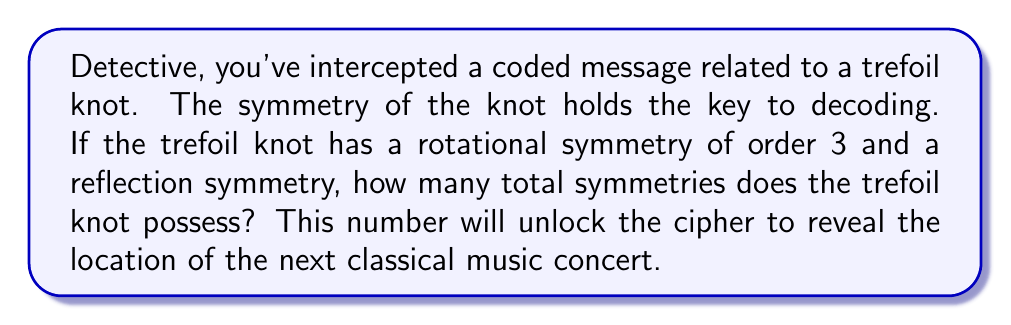Provide a solution to this math problem. Let's approach this step-by-step:

1) First, recall that the trefoil knot is chiral, meaning it's not equivalent to its mirror image.

2) The symmetries of a trefoil knot form a group. Let's identify the elements:

   a) Rotational symmetry of order 3: This means there are 3 rotations that leave the knot unchanged.
      - Identity rotation (0°)
      - Rotation by 120°
      - Rotation by 240°

   b) Reflection symmetry: There is one reflection plane.

3) Now, we need to consider the interaction of these symmetries:

   - Each rotation can be followed by either no reflection or a reflection.
   - This gives us two sets of symmetries:
     Set 1: The 3 rotations without reflection
     Set 2: The 3 rotations followed by the reflection

4) To calculate the total number of symmetries:
   $$\text{Total symmetries} = |\text{Set 1}| + |\text{Set 2}| = 3 + 3 = 6$$

5) This result is consistent with the fact that the symmetry group of the trefoil knot is isomorphic to the dihedral group $D_3$, which has order 6.

Therefore, the trefoil knot has 6 total symmetries.
Answer: 6 